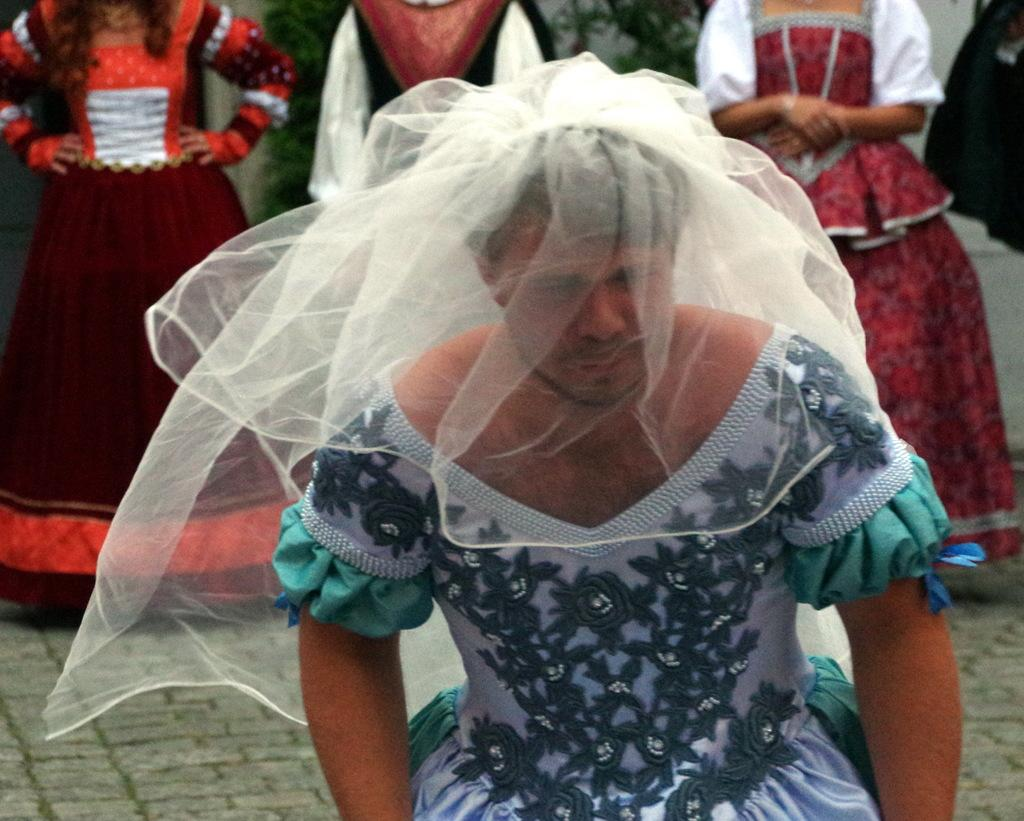What is the main subject of the image? There is a person on the ground in the image. Can you describe the surroundings of the person? There are persons visible in the background of the image. What type of impulse can be seen affecting the person in the image? There is no impulse visible in the image; it is a static scene. Can you describe the cobweb present on the person in the image? There is no cobweb present on the person or in the image. 